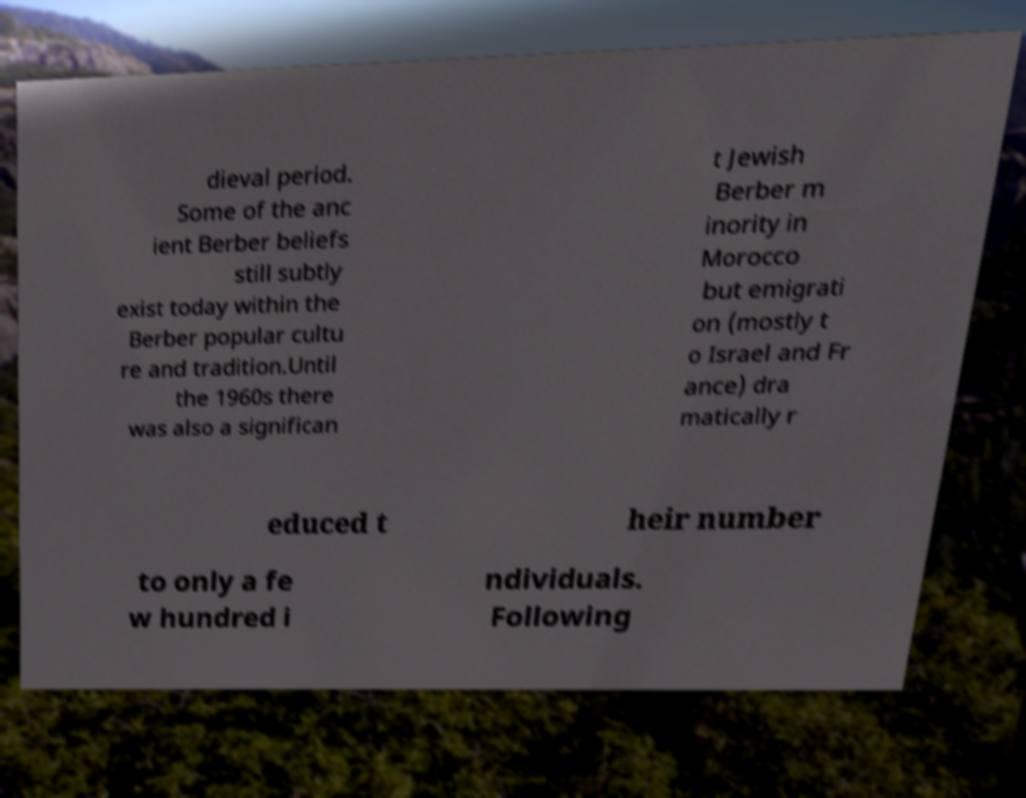Could you extract and type out the text from this image? dieval period. Some of the anc ient Berber beliefs still subtly exist today within the Berber popular cultu re and tradition.Until the 1960s there was also a significan t Jewish Berber m inority in Morocco but emigrati on (mostly t o Israel and Fr ance) dra matically r educed t heir number to only a fe w hundred i ndividuals. Following 